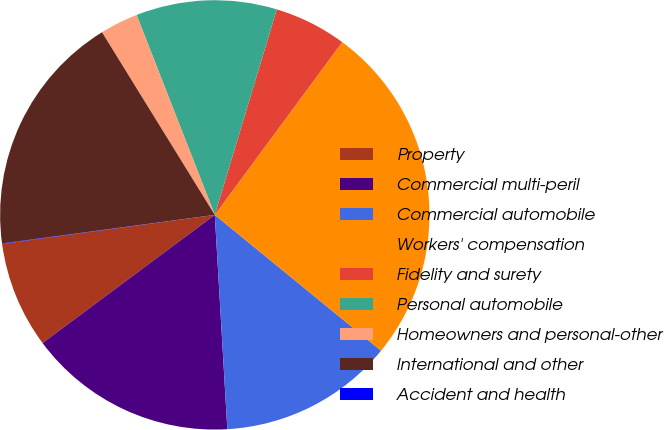Convert chart to OTSL. <chart><loc_0><loc_0><loc_500><loc_500><pie_chart><fcel>Property<fcel>Commercial multi-peril<fcel>Commercial automobile<fcel>Workers' compensation<fcel>Fidelity and surety<fcel>Personal automobile<fcel>Homeowners and personal-other<fcel>International and other<fcel>Accident and health<nl><fcel>8.02%<fcel>15.75%<fcel>13.17%<fcel>25.79%<fcel>5.45%<fcel>10.6%<fcel>2.87%<fcel>18.32%<fcel>0.04%<nl></chart> 